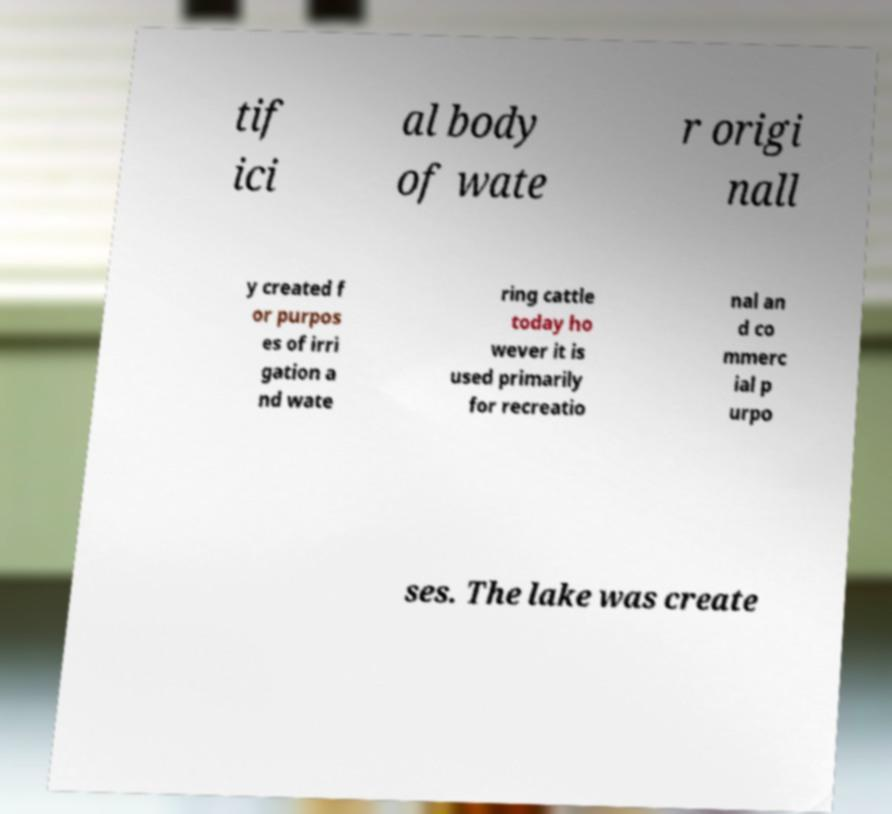Could you extract and type out the text from this image? tif ici al body of wate r origi nall y created f or purpos es of irri gation a nd wate ring cattle today ho wever it is used primarily for recreatio nal an d co mmerc ial p urpo ses. The lake was create 